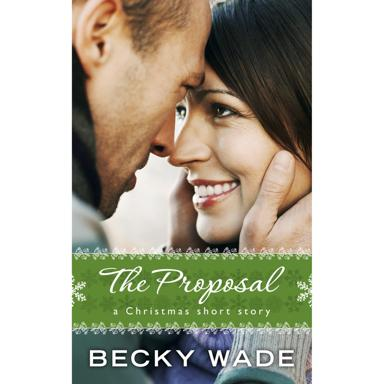What is the title and author of the short story mentioned in the image?
 The title of the short story is "The Proposal" and it is a Christmas short story written by Becky Wade. What is the setting of the image? The setting of the image shows a couple looking at each other, with a green banner in the background. 